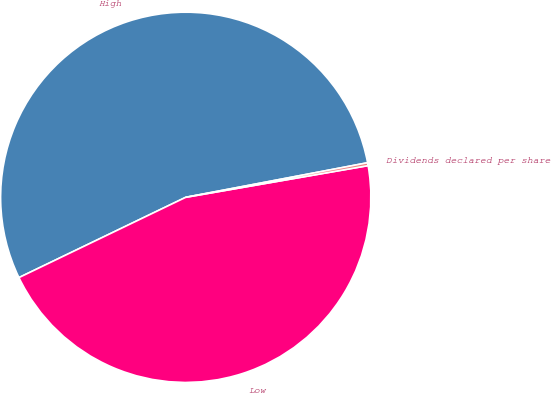Convert chart. <chart><loc_0><loc_0><loc_500><loc_500><pie_chart><fcel>High<fcel>Low<fcel>Dividends declared per share<nl><fcel>54.15%<fcel>45.6%<fcel>0.25%<nl></chart> 